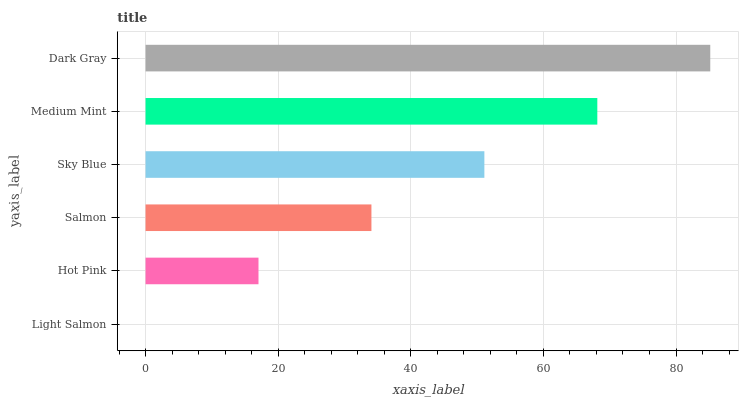Is Light Salmon the minimum?
Answer yes or no. Yes. Is Dark Gray the maximum?
Answer yes or no. Yes. Is Hot Pink the minimum?
Answer yes or no. No. Is Hot Pink the maximum?
Answer yes or no. No. Is Hot Pink greater than Light Salmon?
Answer yes or no. Yes. Is Light Salmon less than Hot Pink?
Answer yes or no. Yes. Is Light Salmon greater than Hot Pink?
Answer yes or no. No. Is Hot Pink less than Light Salmon?
Answer yes or no. No. Is Sky Blue the high median?
Answer yes or no. Yes. Is Salmon the low median?
Answer yes or no. Yes. Is Light Salmon the high median?
Answer yes or no. No. Is Dark Gray the low median?
Answer yes or no. No. 